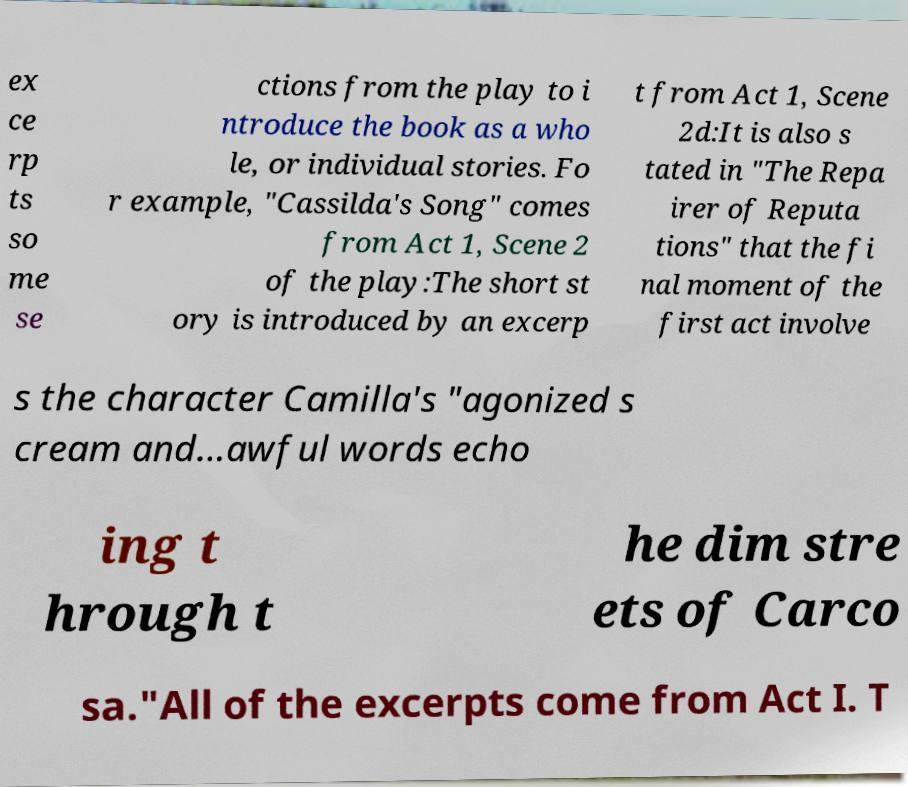Can you read and provide the text displayed in the image?This photo seems to have some interesting text. Can you extract and type it out for me? ex ce rp ts so me se ctions from the play to i ntroduce the book as a who le, or individual stories. Fo r example, "Cassilda's Song" comes from Act 1, Scene 2 of the play:The short st ory is introduced by an excerp t from Act 1, Scene 2d:It is also s tated in "The Repa irer of Reputa tions" that the fi nal moment of the first act involve s the character Camilla's "agonized s cream and...awful words echo ing t hrough t he dim stre ets of Carco sa."All of the excerpts come from Act I. T 